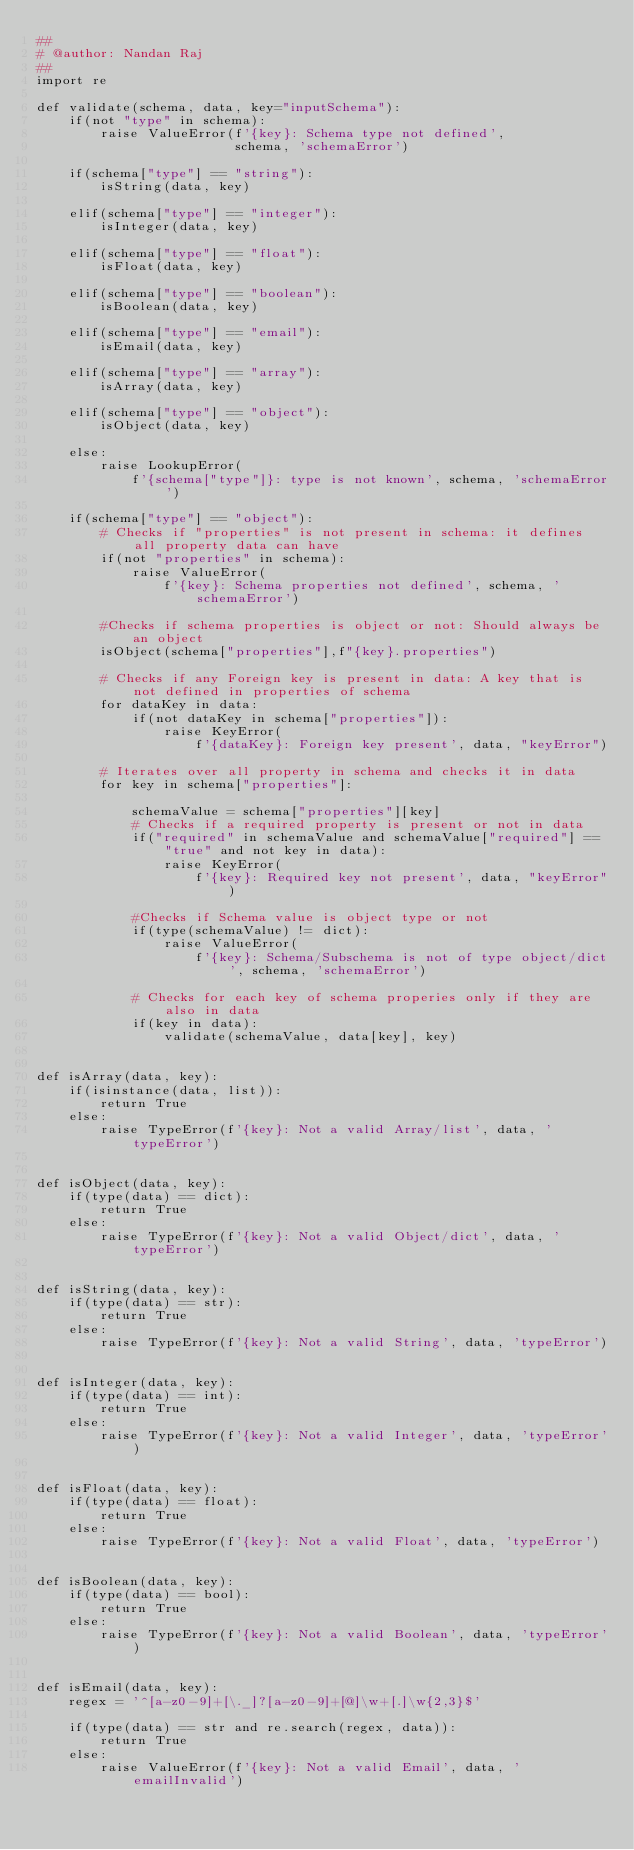<code> <loc_0><loc_0><loc_500><loc_500><_Python_>##
# @author: Nandan Raj
##
import re

def validate(schema, data, key="inputSchema"):
    if(not "type" in schema):
        raise ValueError(f'{key}: Schema type not defined',
                         schema, 'schemaError')

    if(schema["type"] == "string"):
        isString(data, key)

    elif(schema["type"] == "integer"):
        isInteger(data, key)

    elif(schema["type"] == "float"):
        isFloat(data, key)

    elif(schema["type"] == "boolean"):
        isBoolean(data, key)

    elif(schema["type"] == "email"):
        isEmail(data, key)

    elif(schema["type"] == "array"):
        isArray(data, key)

    elif(schema["type"] == "object"):
        isObject(data, key)

    else:
        raise LookupError(
            f'{schema["type"]}: type is not known', schema, 'schemaError')

    if(schema["type"] == "object"):
        # Checks if "properties" is not present in schema: it defines all property data can have
        if(not "properties" in schema):
            raise ValueError(
                f'{key}: Schema properties not defined', schema, 'schemaError')

        #Checks if schema properties is object or not: Should always be an object 
        isObject(schema["properties"],f"{key}.properties")

        # Checks if any Foreign key is present in data: A key that is not defined in properties of schema
        for dataKey in data:
            if(not dataKey in schema["properties"]):
                raise KeyError(
                    f'{dataKey}: Foreign key present', data, "keyError")

        # Iterates over all property in schema and checks it in data
        for key in schema["properties"]:

            schemaValue = schema["properties"][key]
            # Checks if a required property is present or not in data
            if("required" in schemaValue and schemaValue["required"] == "true" and not key in data):
                raise KeyError(
                    f'{key}: Required key not present', data, "keyError")

            #Checks if Schema value is object type or not
            if(type(schemaValue) != dict):
                raise ValueError(
                    f'{key}: Schema/Subschema is not of type object/dict', schema, 'schemaError')

            # Checks for each key of schema properies only if they are also in data
            if(key in data):
                validate(schemaValue, data[key], key)


def isArray(data, key):
    if(isinstance(data, list)):
        return True
    else:
        raise TypeError(f'{key}: Not a valid Array/list', data, 'typeError')


def isObject(data, key):
    if(type(data) == dict):
        return True
    else:
        raise TypeError(f'{key}: Not a valid Object/dict', data, 'typeError')


def isString(data, key):
    if(type(data) == str):
        return True
    else:
        raise TypeError(f'{key}: Not a valid String', data, 'typeError')


def isInteger(data, key):
    if(type(data) == int):
        return True
    else:
        raise TypeError(f'{key}: Not a valid Integer', data, 'typeError')


def isFloat(data, key):
    if(type(data) == float):
        return True
    else:
        raise TypeError(f'{key}: Not a valid Float', data, 'typeError')


def isBoolean(data, key):
    if(type(data) == bool):
        return True
    else:
        raise TypeError(f'{key}: Not a valid Boolean', data, 'typeError')


def isEmail(data, key):
    regex = '^[a-z0-9]+[\._]?[a-z0-9]+[@]\w+[.]\w{2,3}$'

    if(type(data) == str and re.search(regex, data)):
        return True
    else:
        raise ValueError(f'{key}: Not a valid Email', data, 'emailInvalid')
</code> 